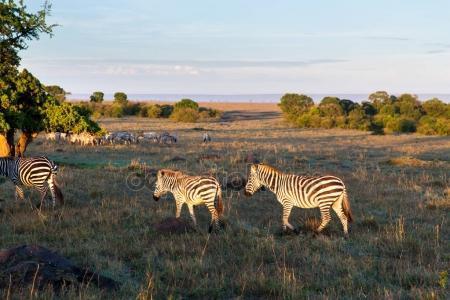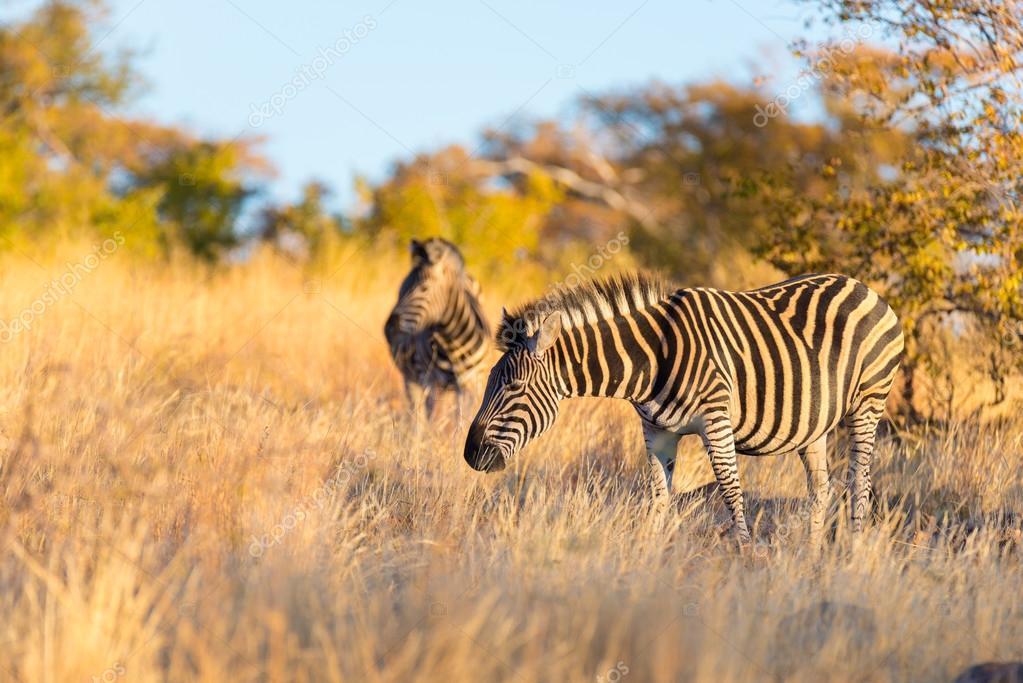The first image is the image on the left, the second image is the image on the right. Analyze the images presented: Is the assertion "The right image features a row of zebras with their bodies facing rightward." valid? Answer yes or no. No. The first image is the image on the left, the second image is the image on the right. Considering the images on both sides, is "In at least one image is a row of zebra going right and in the other image there is is a large group of zebra in different directions." valid? Answer yes or no. No. 